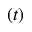<formula> <loc_0><loc_0><loc_500><loc_500>\ r ( t )</formula> 